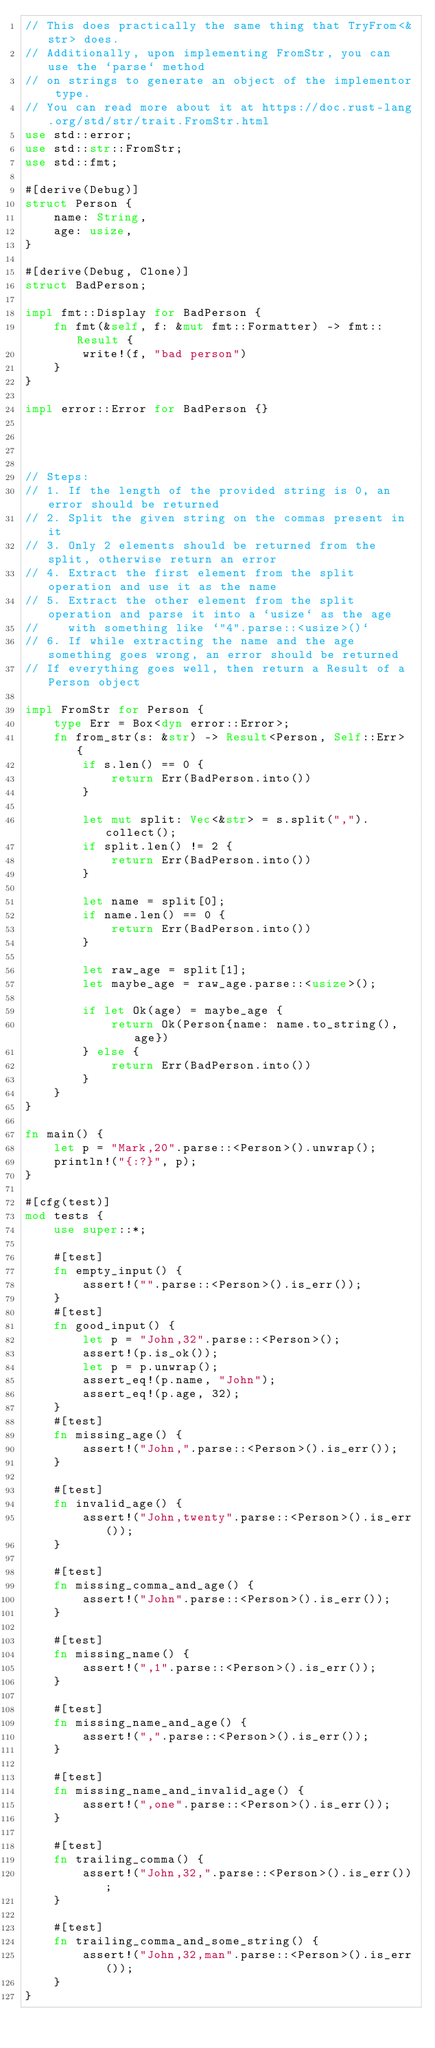Convert code to text. <code><loc_0><loc_0><loc_500><loc_500><_Rust_>// This does practically the same thing that TryFrom<&str> does.
// Additionally, upon implementing FromStr, you can use the `parse` method
// on strings to generate an object of the implementor type.
// You can read more about it at https://doc.rust-lang.org/std/str/trait.FromStr.html
use std::error;
use std::str::FromStr;
use std::fmt;

#[derive(Debug)]
struct Person {
    name: String,
    age: usize,
}

#[derive(Debug, Clone)]
struct BadPerson;

impl fmt::Display for BadPerson {
    fn fmt(&self, f: &mut fmt::Formatter) -> fmt::Result {
        write!(f, "bad person")
    }
}

impl error::Error for BadPerson {}




// Steps:
// 1. If the length of the provided string is 0, an error should be returned
// 2. Split the given string on the commas present in it
// 3. Only 2 elements should be returned from the split, otherwise return an error
// 4. Extract the first element from the split operation and use it as the name
// 5. Extract the other element from the split operation and parse it into a `usize` as the age
//    with something like `"4".parse::<usize>()`
// 6. If while extracting the name and the age something goes wrong, an error should be returned
// If everything goes well, then return a Result of a Person object

impl FromStr for Person {
    type Err = Box<dyn error::Error>;
    fn from_str(s: &str) -> Result<Person, Self::Err> {
        if s.len() == 0 {
            return Err(BadPerson.into())
        }

        let mut split: Vec<&str> = s.split(",").collect();
        if split.len() != 2 {
            return Err(BadPerson.into())
        }

        let name = split[0];
        if name.len() == 0 {
            return Err(BadPerson.into())
        }

        let raw_age = split[1];
        let maybe_age = raw_age.parse::<usize>();

        if let Ok(age) = maybe_age {
            return Ok(Person{name: name.to_string(), age})
        } else {
            return Err(BadPerson.into())
        }
    }
}

fn main() {
    let p = "Mark,20".parse::<Person>().unwrap();
    println!("{:?}", p);
}

#[cfg(test)]
mod tests {
    use super::*;

    #[test]
    fn empty_input() {
        assert!("".parse::<Person>().is_err());
    }
    #[test]
    fn good_input() {
        let p = "John,32".parse::<Person>();
        assert!(p.is_ok());
        let p = p.unwrap();
        assert_eq!(p.name, "John");
        assert_eq!(p.age, 32);
    }
    #[test]
    fn missing_age() {
        assert!("John,".parse::<Person>().is_err());
    }

    #[test]
    fn invalid_age() {
        assert!("John,twenty".parse::<Person>().is_err());
    }

    #[test]
    fn missing_comma_and_age() {
        assert!("John".parse::<Person>().is_err());
    }

    #[test]
    fn missing_name() {
        assert!(",1".parse::<Person>().is_err());
    }

    #[test]
    fn missing_name_and_age() {
        assert!(",".parse::<Person>().is_err());
    }

    #[test]
    fn missing_name_and_invalid_age() {
        assert!(",one".parse::<Person>().is_err());
    }

    #[test]
    fn trailing_comma() {
        assert!("John,32,".parse::<Person>().is_err());
    }

    #[test]
    fn trailing_comma_and_some_string() {
        assert!("John,32,man".parse::<Person>().is_err());
    }
}
</code> 